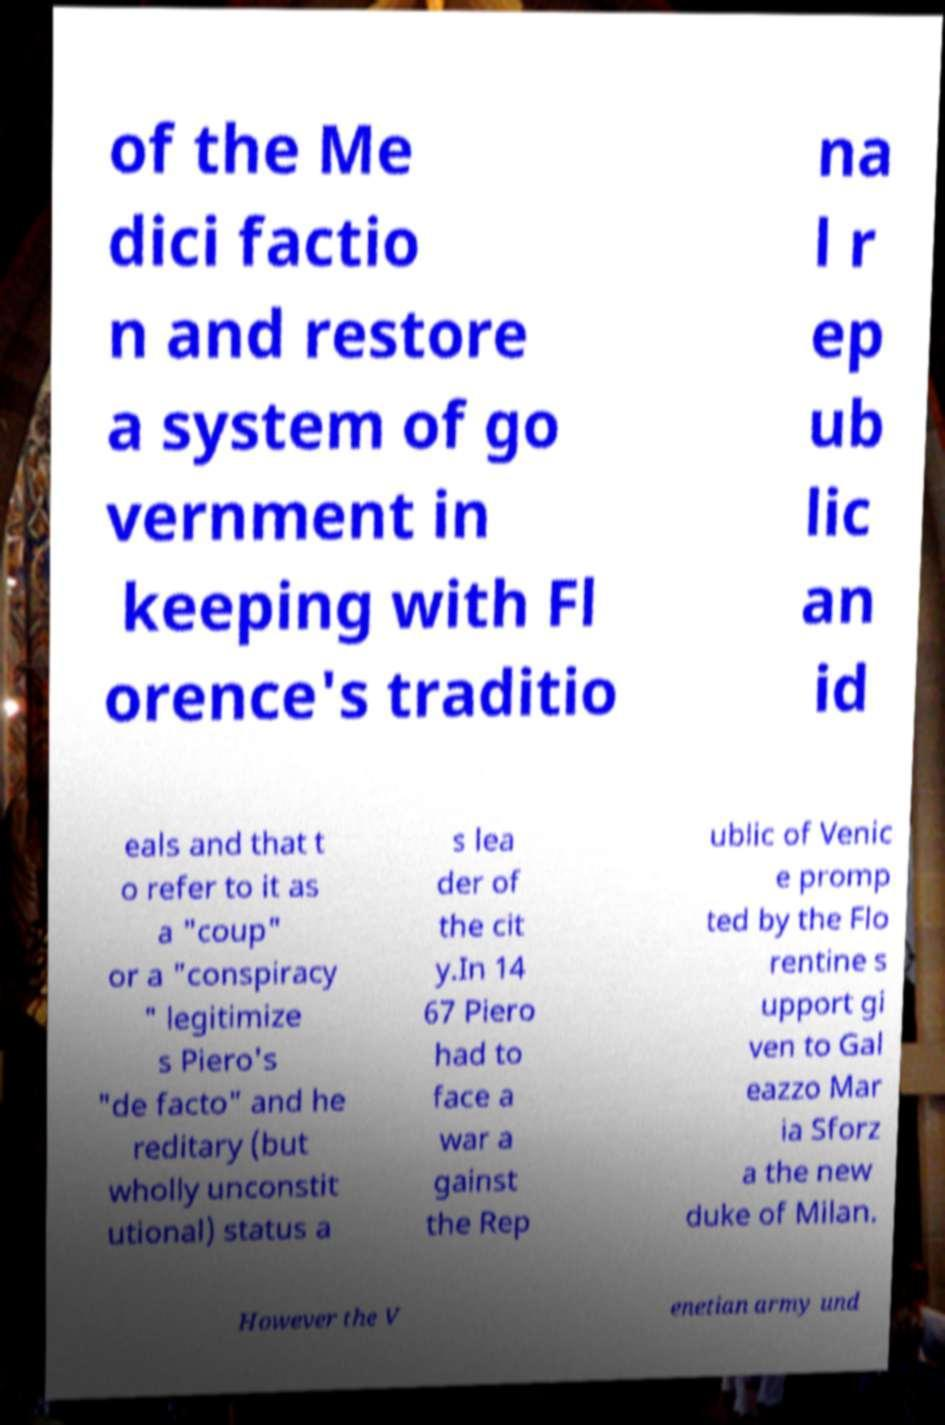For documentation purposes, I need the text within this image transcribed. Could you provide that? of the Me dici factio n and restore a system of go vernment in keeping with Fl orence's traditio na l r ep ub lic an id eals and that t o refer to it as a "coup" or a "conspiracy " legitimize s Piero's "de facto" and he reditary (but wholly unconstit utional) status a s lea der of the cit y.In 14 67 Piero had to face a war a gainst the Rep ublic of Venic e promp ted by the Flo rentine s upport gi ven to Gal eazzo Mar ia Sforz a the new duke of Milan. However the V enetian army und 